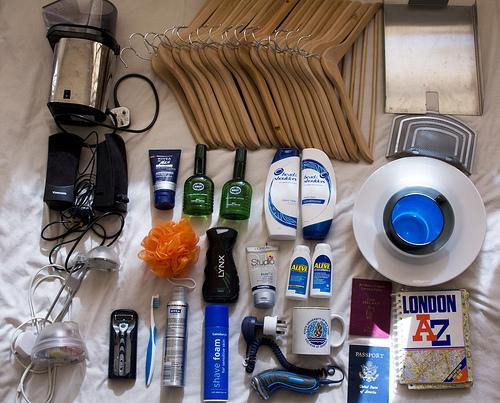Enumerate the hygiene-related products seen in the image and mention their colors. Wooden V-neck hangers, white and blue toothbrush, black shaving razor, green nail polish, head and shoulders shampoo, blue electric razor, black bottle of Lynx, orange loofah sponge, and blue can of shave foam. Specify the main objects displayed in the image, accompanied by their prominent colors and features. Wooden V-neck hangers, short white bottles with blue labels, a leg razor, a soft head toothbrush, a small facial lamp, an orange sponge, a map of London, a passport, and personal hygiene toiletries. Briefly describe the dominant theme of the image by mentioning a few standout items. An assortment of personal hygiene products, including wooden hangers, toothbrushes, razors, sponges, and bottles for toiletries. Identify the primary theme of the image and provide brief descriptions of the items connected to it. Personal hygiene and daily grooming essentials, such as wooden hangers, toothbrushes, razors, sponges, and various toiletry bottles. Point out notable objects in the image connected to daily routines and their visual aspects. A soft head toothbrush, black shaving razor, a small facial lamp, a white and blue toothbrush, a green nail polish, and two bottles of head and shoulders shampoo. Mention the key objects in the image related to travel, along with their main characteristics. A map of London, a passport on a bed, planning trip London England, and necessary documents for other countries. Name a few objects present in the image which are associated with domestic life, along with their characteristics. A small facial lamp, wooden closet garment hangers, a white mug with a blue design, a bright orange sponge, and a blue and white toothbrush. List the main objects in the image associated with preparing for a trip, together with their key features. A map of London, a passport, planning a trip to London England, and necessary documents for traveling to other countries. Locate the key items in the image that are associated with personal grooming and identify their colors. A black shaving razor, green nail polish, head and shoulders shampoo, a blue electric razor, a white and blue toothbrush, and an orange loofah sponge. Enumerate the products intended for hair and skin care visible in the image, accompanied by their colors. Head and shoulders shampoo, black shaving razor, blue electric razor, green nail polish, tube of studio hair gel, and an orange loofah sponge. 